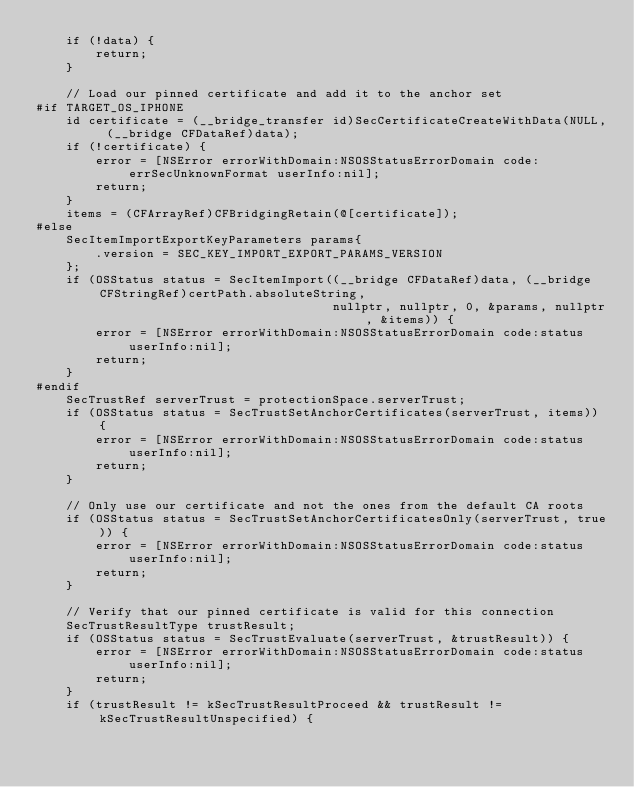<code> <loc_0><loc_0><loc_500><loc_500><_ObjectiveC_>    if (!data) {
        return;
    }

    // Load our pinned certificate and add it to the anchor set
#if TARGET_OS_IPHONE
    id certificate = (__bridge_transfer id)SecCertificateCreateWithData(NULL, (__bridge CFDataRef)data);
    if (!certificate) {
        error = [NSError errorWithDomain:NSOSStatusErrorDomain code:errSecUnknownFormat userInfo:nil];
        return;
    }
    items = (CFArrayRef)CFBridgingRetain(@[certificate]);
#else
    SecItemImportExportKeyParameters params{
        .version = SEC_KEY_IMPORT_EXPORT_PARAMS_VERSION
    };
    if (OSStatus status = SecItemImport((__bridge CFDataRef)data, (__bridge CFStringRef)certPath.absoluteString,
                                        nullptr, nullptr, 0, &params, nullptr, &items)) {
        error = [NSError errorWithDomain:NSOSStatusErrorDomain code:status userInfo:nil];
        return;
    }
#endif
    SecTrustRef serverTrust = protectionSpace.serverTrust;
    if (OSStatus status = SecTrustSetAnchorCertificates(serverTrust, items)) {
        error = [NSError errorWithDomain:NSOSStatusErrorDomain code:status userInfo:nil];
        return;
    }

    // Only use our certificate and not the ones from the default CA roots
    if (OSStatus status = SecTrustSetAnchorCertificatesOnly(serverTrust, true)) {
        error = [NSError errorWithDomain:NSOSStatusErrorDomain code:status userInfo:nil];
        return;
    }

    // Verify that our pinned certificate is valid for this connection
    SecTrustResultType trustResult;
    if (OSStatus status = SecTrustEvaluate(serverTrust, &trustResult)) {
        error = [NSError errorWithDomain:NSOSStatusErrorDomain code:status userInfo:nil];
        return;
    }
    if (trustResult != kSecTrustResultProceed && trustResult != kSecTrustResultUnspecified) {</code> 